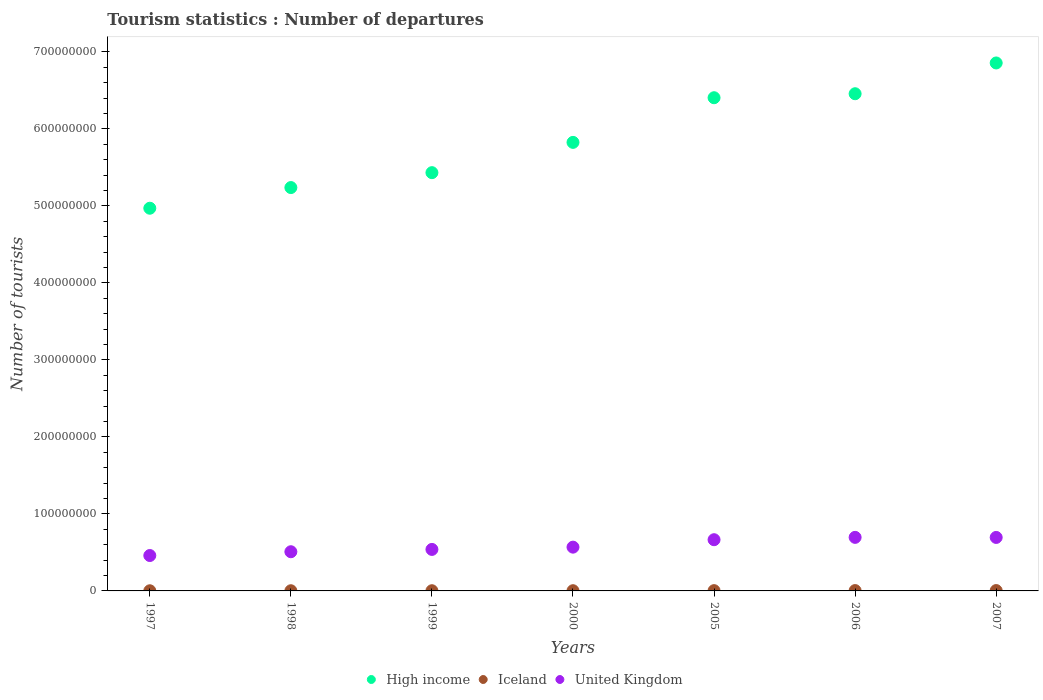How many different coloured dotlines are there?
Offer a terse response. 3. Is the number of dotlines equal to the number of legend labels?
Keep it short and to the point. Yes. What is the number of tourist departures in Iceland in 1999?
Offer a terse response. 2.57e+05. Across all years, what is the maximum number of tourist departures in United Kingdom?
Keep it short and to the point. 6.95e+07. Across all years, what is the minimum number of tourist departures in High income?
Provide a short and direct response. 4.97e+08. In which year was the number of tourist departures in United Kingdom maximum?
Give a very brief answer. 2006. In which year was the number of tourist departures in High income minimum?
Give a very brief answer. 1997. What is the total number of tourist departures in United Kingdom in the graph?
Offer a very short reply. 4.13e+08. What is the difference between the number of tourist departures in United Kingdom in 2006 and that in 2007?
Your answer should be compact. 8.60e+04. What is the difference between the number of tourist departures in Iceland in 2000 and the number of tourist departures in High income in 2005?
Offer a very short reply. -6.40e+08. What is the average number of tourist departures in Iceland per year?
Provide a succinct answer. 3.19e+05. In the year 2006, what is the difference between the number of tourist departures in Iceland and number of tourist departures in High income?
Your response must be concise. -6.45e+08. In how many years, is the number of tourist departures in Iceland greater than 200000000?
Give a very brief answer. 0. What is the ratio of the number of tourist departures in Iceland in 2000 to that in 2005?
Offer a terse response. 0.78. Is the difference between the number of tourist departures in Iceland in 1998 and 1999 greater than the difference between the number of tourist departures in High income in 1998 and 1999?
Provide a succinct answer. Yes. What is the difference between the highest and the second highest number of tourist departures in Iceland?
Keep it short and to the point. 2.00e+04. What is the difference between the highest and the lowest number of tourist departures in High income?
Ensure brevity in your answer.  1.89e+08. Is it the case that in every year, the sum of the number of tourist departures in United Kingdom and number of tourist departures in High income  is greater than the number of tourist departures in Iceland?
Make the answer very short. Yes. Does the number of tourist departures in United Kingdom monotonically increase over the years?
Give a very brief answer. No. Is the number of tourist departures in United Kingdom strictly greater than the number of tourist departures in High income over the years?
Ensure brevity in your answer.  No. How many dotlines are there?
Offer a terse response. 3. What is the difference between two consecutive major ticks on the Y-axis?
Provide a succinct answer. 1.00e+08. Are the values on the major ticks of Y-axis written in scientific E-notation?
Offer a very short reply. No. Does the graph contain any zero values?
Your answer should be very brief. No. Where does the legend appear in the graph?
Your answer should be very brief. Bottom center. How are the legend labels stacked?
Offer a terse response. Horizontal. What is the title of the graph?
Your answer should be compact. Tourism statistics : Number of departures. What is the label or title of the Y-axis?
Provide a succinct answer. Number of tourists. What is the Number of tourists in High income in 1997?
Keep it short and to the point. 4.97e+08. What is the Number of tourists of Iceland in 1997?
Ensure brevity in your answer.  2.03e+05. What is the Number of tourists in United Kingdom in 1997?
Your answer should be compact. 4.60e+07. What is the Number of tourists in High income in 1998?
Make the answer very short. 5.24e+08. What is the Number of tourists in Iceland in 1998?
Provide a succinct answer. 2.27e+05. What is the Number of tourists in United Kingdom in 1998?
Provide a short and direct response. 5.09e+07. What is the Number of tourists of High income in 1999?
Provide a short and direct response. 5.43e+08. What is the Number of tourists in Iceland in 1999?
Ensure brevity in your answer.  2.57e+05. What is the Number of tourists in United Kingdom in 1999?
Keep it short and to the point. 5.39e+07. What is the Number of tourists of High income in 2000?
Your response must be concise. 5.82e+08. What is the Number of tourists in Iceland in 2000?
Your answer should be compact. 2.83e+05. What is the Number of tourists in United Kingdom in 2000?
Offer a terse response. 5.68e+07. What is the Number of tourists in High income in 2005?
Offer a very short reply. 6.40e+08. What is the Number of tourists in Iceland in 2005?
Your response must be concise. 3.64e+05. What is the Number of tourists in United Kingdom in 2005?
Provide a succinct answer. 6.65e+07. What is the Number of tourists of High income in 2006?
Ensure brevity in your answer.  6.46e+08. What is the Number of tourists of Iceland in 2006?
Provide a short and direct response. 4.40e+05. What is the Number of tourists in United Kingdom in 2006?
Keep it short and to the point. 6.95e+07. What is the Number of tourists in High income in 2007?
Offer a terse response. 6.85e+08. What is the Number of tourists in Iceland in 2007?
Give a very brief answer. 4.60e+05. What is the Number of tourists of United Kingdom in 2007?
Keep it short and to the point. 6.94e+07. Across all years, what is the maximum Number of tourists in High income?
Make the answer very short. 6.85e+08. Across all years, what is the maximum Number of tourists of United Kingdom?
Ensure brevity in your answer.  6.95e+07. Across all years, what is the minimum Number of tourists of High income?
Provide a short and direct response. 4.97e+08. Across all years, what is the minimum Number of tourists in Iceland?
Offer a very short reply. 2.03e+05. Across all years, what is the minimum Number of tourists of United Kingdom?
Your answer should be compact. 4.60e+07. What is the total Number of tourists of High income in the graph?
Ensure brevity in your answer.  4.12e+09. What is the total Number of tourists of Iceland in the graph?
Offer a terse response. 2.23e+06. What is the total Number of tourists in United Kingdom in the graph?
Keep it short and to the point. 4.13e+08. What is the difference between the Number of tourists of High income in 1997 and that in 1998?
Offer a very short reply. -2.68e+07. What is the difference between the Number of tourists of Iceland in 1997 and that in 1998?
Your response must be concise. -2.40e+04. What is the difference between the Number of tourists of United Kingdom in 1997 and that in 1998?
Your answer should be compact. -4.92e+06. What is the difference between the Number of tourists in High income in 1997 and that in 1999?
Offer a very short reply. -4.62e+07. What is the difference between the Number of tourists in Iceland in 1997 and that in 1999?
Provide a succinct answer. -5.40e+04. What is the difference between the Number of tourists in United Kingdom in 1997 and that in 1999?
Make the answer very short. -7.92e+06. What is the difference between the Number of tourists in High income in 1997 and that in 2000?
Offer a very short reply. -8.55e+07. What is the difference between the Number of tourists of Iceland in 1997 and that in 2000?
Provide a succinct answer. -8.00e+04. What is the difference between the Number of tourists of United Kingdom in 1997 and that in 2000?
Provide a short and direct response. -1.09e+07. What is the difference between the Number of tourists of High income in 1997 and that in 2005?
Your answer should be compact. -1.43e+08. What is the difference between the Number of tourists in Iceland in 1997 and that in 2005?
Your response must be concise. -1.61e+05. What is the difference between the Number of tourists of United Kingdom in 1997 and that in 2005?
Provide a succinct answer. -2.05e+07. What is the difference between the Number of tourists in High income in 1997 and that in 2006?
Your answer should be very brief. -1.49e+08. What is the difference between the Number of tourists in Iceland in 1997 and that in 2006?
Provide a short and direct response. -2.37e+05. What is the difference between the Number of tourists of United Kingdom in 1997 and that in 2006?
Give a very brief answer. -2.36e+07. What is the difference between the Number of tourists of High income in 1997 and that in 2007?
Your answer should be very brief. -1.89e+08. What is the difference between the Number of tourists in Iceland in 1997 and that in 2007?
Your response must be concise. -2.57e+05. What is the difference between the Number of tourists of United Kingdom in 1997 and that in 2007?
Your answer should be very brief. -2.35e+07. What is the difference between the Number of tourists of High income in 1998 and that in 1999?
Your answer should be compact. -1.94e+07. What is the difference between the Number of tourists in United Kingdom in 1998 and that in 1999?
Offer a terse response. -3.01e+06. What is the difference between the Number of tourists of High income in 1998 and that in 2000?
Make the answer very short. -5.87e+07. What is the difference between the Number of tourists of Iceland in 1998 and that in 2000?
Your response must be concise. -5.60e+04. What is the difference between the Number of tourists in United Kingdom in 1998 and that in 2000?
Ensure brevity in your answer.  -5.96e+06. What is the difference between the Number of tourists in High income in 1998 and that in 2005?
Your answer should be compact. -1.17e+08. What is the difference between the Number of tourists in Iceland in 1998 and that in 2005?
Ensure brevity in your answer.  -1.37e+05. What is the difference between the Number of tourists in United Kingdom in 1998 and that in 2005?
Offer a terse response. -1.56e+07. What is the difference between the Number of tourists in High income in 1998 and that in 2006?
Make the answer very short. -1.22e+08. What is the difference between the Number of tourists in Iceland in 1998 and that in 2006?
Ensure brevity in your answer.  -2.13e+05. What is the difference between the Number of tourists of United Kingdom in 1998 and that in 2006?
Provide a short and direct response. -1.87e+07. What is the difference between the Number of tourists of High income in 1998 and that in 2007?
Give a very brief answer. -1.62e+08. What is the difference between the Number of tourists in Iceland in 1998 and that in 2007?
Your answer should be compact. -2.33e+05. What is the difference between the Number of tourists of United Kingdom in 1998 and that in 2007?
Provide a succinct answer. -1.86e+07. What is the difference between the Number of tourists in High income in 1999 and that in 2000?
Ensure brevity in your answer.  -3.93e+07. What is the difference between the Number of tourists in Iceland in 1999 and that in 2000?
Offer a terse response. -2.60e+04. What is the difference between the Number of tourists of United Kingdom in 1999 and that in 2000?
Make the answer very short. -2.96e+06. What is the difference between the Number of tourists of High income in 1999 and that in 2005?
Your answer should be compact. -9.73e+07. What is the difference between the Number of tourists in Iceland in 1999 and that in 2005?
Make the answer very short. -1.07e+05. What is the difference between the Number of tourists of United Kingdom in 1999 and that in 2005?
Your answer should be compact. -1.26e+07. What is the difference between the Number of tourists of High income in 1999 and that in 2006?
Keep it short and to the point. -1.02e+08. What is the difference between the Number of tourists of Iceland in 1999 and that in 2006?
Your answer should be very brief. -1.83e+05. What is the difference between the Number of tourists of United Kingdom in 1999 and that in 2006?
Ensure brevity in your answer.  -1.57e+07. What is the difference between the Number of tourists of High income in 1999 and that in 2007?
Offer a very short reply. -1.42e+08. What is the difference between the Number of tourists of Iceland in 1999 and that in 2007?
Your answer should be compact. -2.03e+05. What is the difference between the Number of tourists of United Kingdom in 1999 and that in 2007?
Offer a terse response. -1.56e+07. What is the difference between the Number of tourists in High income in 2000 and that in 2005?
Provide a short and direct response. -5.80e+07. What is the difference between the Number of tourists in Iceland in 2000 and that in 2005?
Your answer should be compact. -8.10e+04. What is the difference between the Number of tourists in United Kingdom in 2000 and that in 2005?
Provide a short and direct response. -9.66e+06. What is the difference between the Number of tourists of High income in 2000 and that in 2006?
Ensure brevity in your answer.  -6.32e+07. What is the difference between the Number of tourists in Iceland in 2000 and that in 2006?
Give a very brief answer. -1.57e+05. What is the difference between the Number of tourists of United Kingdom in 2000 and that in 2006?
Make the answer very short. -1.27e+07. What is the difference between the Number of tourists in High income in 2000 and that in 2007?
Provide a short and direct response. -1.03e+08. What is the difference between the Number of tourists of Iceland in 2000 and that in 2007?
Keep it short and to the point. -1.77e+05. What is the difference between the Number of tourists in United Kingdom in 2000 and that in 2007?
Provide a succinct answer. -1.26e+07. What is the difference between the Number of tourists in High income in 2005 and that in 2006?
Your answer should be compact. -5.19e+06. What is the difference between the Number of tourists in Iceland in 2005 and that in 2006?
Keep it short and to the point. -7.60e+04. What is the difference between the Number of tourists of United Kingdom in 2005 and that in 2006?
Keep it short and to the point. -3.04e+06. What is the difference between the Number of tourists in High income in 2005 and that in 2007?
Give a very brief answer. -4.51e+07. What is the difference between the Number of tourists in Iceland in 2005 and that in 2007?
Make the answer very short. -9.60e+04. What is the difference between the Number of tourists in United Kingdom in 2005 and that in 2007?
Ensure brevity in your answer.  -2.96e+06. What is the difference between the Number of tourists of High income in 2006 and that in 2007?
Provide a short and direct response. -3.99e+07. What is the difference between the Number of tourists in United Kingdom in 2006 and that in 2007?
Ensure brevity in your answer.  8.60e+04. What is the difference between the Number of tourists of High income in 1997 and the Number of tourists of Iceland in 1998?
Offer a very short reply. 4.97e+08. What is the difference between the Number of tourists in High income in 1997 and the Number of tourists in United Kingdom in 1998?
Your answer should be very brief. 4.46e+08. What is the difference between the Number of tourists in Iceland in 1997 and the Number of tourists in United Kingdom in 1998?
Offer a very short reply. -5.07e+07. What is the difference between the Number of tourists in High income in 1997 and the Number of tourists in Iceland in 1999?
Provide a succinct answer. 4.97e+08. What is the difference between the Number of tourists in High income in 1997 and the Number of tourists in United Kingdom in 1999?
Ensure brevity in your answer.  4.43e+08. What is the difference between the Number of tourists of Iceland in 1997 and the Number of tourists of United Kingdom in 1999?
Your answer should be very brief. -5.37e+07. What is the difference between the Number of tourists in High income in 1997 and the Number of tourists in Iceland in 2000?
Offer a very short reply. 4.97e+08. What is the difference between the Number of tourists of High income in 1997 and the Number of tourists of United Kingdom in 2000?
Offer a very short reply. 4.40e+08. What is the difference between the Number of tourists in Iceland in 1997 and the Number of tourists in United Kingdom in 2000?
Provide a short and direct response. -5.66e+07. What is the difference between the Number of tourists in High income in 1997 and the Number of tourists in Iceland in 2005?
Provide a succinct answer. 4.97e+08. What is the difference between the Number of tourists in High income in 1997 and the Number of tourists in United Kingdom in 2005?
Offer a very short reply. 4.30e+08. What is the difference between the Number of tourists of Iceland in 1997 and the Number of tourists of United Kingdom in 2005?
Keep it short and to the point. -6.63e+07. What is the difference between the Number of tourists in High income in 1997 and the Number of tourists in Iceland in 2006?
Make the answer very short. 4.96e+08. What is the difference between the Number of tourists of High income in 1997 and the Number of tourists of United Kingdom in 2006?
Offer a very short reply. 4.27e+08. What is the difference between the Number of tourists of Iceland in 1997 and the Number of tourists of United Kingdom in 2006?
Provide a succinct answer. -6.93e+07. What is the difference between the Number of tourists in High income in 1997 and the Number of tourists in Iceland in 2007?
Provide a succinct answer. 4.96e+08. What is the difference between the Number of tourists of High income in 1997 and the Number of tourists of United Kingdom in 2007?
Provide a short and direct response. 4.27e+08. What is the difference between the Number of tourists of Iceland in 1997 and the Number of tourists of United Kingdom in 2007?
Your response must be concise. -6.92e+07. What is the difference between the Number of tourists in High income in 1998 and the Number of tourists in Iceland in 1999?
Provide a succinct answer. 5.23e+08. What is the difference between the Number of tourists of High income in 1998 and the Number of tourists of United Kingdom in 1999?
Provide a short and direct response. 4.70e+08. What is the difference between the Number of tourists in Iceland in 1998 and the Number of tourists in United Kingdom in 1999?
Offer a terse response. -5.37e+07. What is the difference between the Number of tourists of High income in 1998 and the Number of tourists of Iceland in 2000?
Your answer should be very brief. 5.23e+08. What is the difference between the Number of tourists in High income in 1998 and the Number of tourists in United Kingdom in 2000?
Offer a terse response. 4.67e+08. What is the difference between the Number of tourists in Iceland in 1998 and the Number of tourists in United Kingdom in 2000?
Give a very brief answer. -5.66e+07. What is the difference between the Number of tourists in High income in 1998 and the Number of tourists in Iceland in 2005?
Provide a succinct answer. 5.23e+08. What is the difference between the Number of tourists of High income in 1998 and the Number of tourists of United Kingdom in 2005?
Your answer should be compact. 4.57e+08. What is the difference between the Number of tourists in Iceland in 1998 and the Number of tourists in United Kingdom in 2005?
Ensure brevity in your answer.  -6.63e+07. What is the difference between the Number of tourists of High income in 1998 and the Number of tourists of Iceland in 2006?
Offer a very short reply. 5.23e+08. What is the difference between the Number of tourists of High income in 1998 and the Number of tourists of United Kingdom in 2006?
Ensure brevity in your answer.  4.54e+08. What is the difference between the Number of tourists of Iceland in 1998 and the Number of tourists of United Kingdom in 2006?
Offer a terse response. -6.93e+07. What is the difference between the Number of tourists in High income in 1998 and the Number of tourists in Iceland in 2007?
Offer a very short reply. 5.23e+08. What is the difference between the Number of tourists of High income in 1998 and the Number of tourists of United Kingdom in 2007?
Give a very brief answer. 4.54e+08. What is the difference between the Number of tourists of Iceland in 1998 and the Number of tourists of United Kingdom in 2007?
Your answer should be very brief. -6.92e+07. What is the difference between the Number of tourists of High income in 1999 and the Number of tourists of Iceland in 2000?
Ensure brevity in your answer.  5.43e+08. What is the difference between the Number of tourists in High income in 1999 and the Number of tourists in United Kingdom in 2000?
Ensure brevity in your answer.  4.86e+08. What is the difference between the Number of tourists of Iceland in 1999 and the Number of tourists of United Kingdom in 2000?
Make the answer very short. -5.66e+07. What is the difference between the Number of tourists in High income in 1999 and the Number of tourists in Iceland in 2005?
Make the answer very short. 5.43e+08. What is the difference between the Number of tourists of High income in 1999 and the Number of tourists of United Kingdom in 2005?
Your answer should be compact. 4.77e+08. What is the difference between the Number of tourists in Iceland in 1999 and the Number of tourists in United Kingdom in 2005?
Ensure brevity in your answer.  -6.62e+07. What is the difference between the Number of tourists in High income in 1999 and the Number of tourists in Iceland in 2006?
Ensure brevity in your answer.  5.43e+08. What is the difference between the Number of tourists of High income in 1999 and the Number of tourists of United Kingdom in 2006?
Your response must be concise. 4.74e+08. What is the difference between the Number of tourists of Iceland in 1999 and the Number of tourists of United Kingdom in 2006?
Ensure brevity in your answer.  -6.93e+07. What is the difference between the Number of tourists of High income in 1999 and the Number of tourists of Iceland in 2007?
Make the answer very short. 5.43e+08. What is the difference between the Number of tourists in High income in 1999 and the Number of tourists in United Kingdom in 2007?
Your response must be concise. 4.74e+08. What is the difference between the Number of tourists of Iceland in 1999 and the Number of tourists of United Kingdom in 2007?
Make the answer very short. -6.92e+07. What is the difference between the Number of tourists of High income in 2000 and the Number of tourists of Iceland in 2005?
Your answer should be compact. 5.82e+08. What is the difference between the Number of tourists in High income in 2000 and the Number of tourists in United Kingdom in 2005?
Offer a terse response. 5.16e+08. What is the difference between the Number of tourists in Iceland in 2000 and the Number of tourists in United Kingdom in 2005?
Your answer should be very brief. -6.62e+07. What is the difference between the Number of tourists of High income in 2000 and the Number of tourists of Iceland in 2006?
Keep it short and to the point. 5.82e+08. What is the difference between the Number of tourists of High income in 2000 and the Number of tourists of United Kingdom in 2006?
Ensure brevity in your answer.  5.13e+08. What is the difference between the Number of tourists in Iceland in 2000 and the Number of tourists in United Kingdom in 2006?
Keep it short and to the point. -6.93e+07. What is the difference between the Number of tourists of High income in 2000 and the Number of tourists of Iceland in 2007?
Your answer should be very brief. 5.82e+08. What is the difference between the Number of tourists of High income in 2000 and the Number of tourists of United Kingdom in 2007?
Keep it short and to the point. 5.13e+08. What is the difference between the Number of tourists of Iceland in 2000 and the Number of tourists of United Kingdom in 2007?
Give a very brief answer. -6.92e+07. What is the difference between the Number of tourists in High income in 2005 and the Number of tourists in Iceland in 2006?
Provide a short and direct response. 6.40e+08. What is the difference between the Number of tourists of High income in 2005 and the Number of tourists of United Kingdom in 2006?
Keep it short and to the point. 5.71e+08. What is the difference between the Number of tourists in Iceland in 2005 and the Number of tourists in United Kingdom in 2006?
Offer a terse response. -6.92e+07. What is the difference between the Number of tourists of High income in 2005 and the Number of tourists of Iceland in 2007?
Your answer should be compact. 6.40e+08. What is the difference between the Number of tourists in High income in 2005 and the Number of tourists in United Kingdom in 2007?
Ensure brevity in your answer.  5.71e+08. What is the difference between the Number of tourists in Iceland in 2005 and the Number of tourists in United Kingdom in 2007?
Provide a short and direct response. -6.91e+07. What is the difference between the Number of tourists in High income in 2006 and the Number of tourists in Iceland in 2007?
Offer a terse response. 6.45e+08. What is the difference between the Number of tourists in High income in 2006 and the Number of tourists in United Kingdom in 2007?
Make the answer very short. 5.76e+08. What is the difference between the Number of tourists of Iceland in 2006 and the Number of tourists of United Kingdom in 2007?
Your answer should be compact. -6.90e+07. What is the average Number of tourists of High income per year?
Your response must be concise. 5.88e+08. What is the average Number of tourists in Iceland per year?
Offer a terse response. 3.19e+05. What is the average Number of tourists of United Kingdom per year?
Give a very brief answer. 5.90e+07. In the year 1997, what is the difference between the Number of tourists of High income and Number of tourists of Iceland?
Give a very brief answer. 4.97e+08. In the year 1997, what is the difference between the Number of tourists in High income and Number of tourists in United Kingdom?
Keep it short and to the point. 4.51e+08. In the year 1997, what is the difference between the Number of tourists in Iceland and Number of tourists in United Kingdom?
Ensure brevity in your answer.  -4.58e+07. In the year 1998, what is the difference between the Number of tourists of High income and Number of tourists of Iceland?
Offer a terse response. 5.23e+08. In the year 1998, what is the difference between the Number of tourists of High income and Number of tourists of United Kingdom?
Your response must be concise. 4.73e+08. In the year 1998, what is the difference between the Number of tourists of Iceland and Number of tourists of United Kingdom?
Offer a terse response. -5.06e+07. In the year 1999, what is the difference between the Number of tourists in High income and Number of tourists in Iceland?
Offer a terse response. 5.43e+08. In the year 1999, what is the difference between the Number of tourists of High income and Number of tourists of United Kingdom?
Your response must be concise. 4.89e+08. In the year 1999, what is the difference between the Number of tourists of Iceland and Number of tourists of United Kingdom?
Keep it short and to the point. -5.36e+07. In the year 2000, what is the difference between the Number of tourists in High income and Number of tourists in Iceland?
Give a very brief answer. 5.82e+08. In the year 2000, what is the difference between the Number of tourists in High income and Number of tourists in United Kingdom?
Make the answer very short. 5.26e+08. In the year 2000, what is the difference between the Number of tourists in Iceland and Number of tourists in United Kingdom?
Your answer should be very brief. -5.66e+07. In the year 2005, what is the difference between the Number of tourists in High income and Number of tourists in Iceland?
Offer a very short reply. 6.40e+08. In the year 2005, what is the difference between the Number of tourists of High income and Number of tourists of United Kingdom?
Your response must be concise. 5.74e+08. In the year 2005, what is the difference between the Number of tourists in Iceland and Number of tourists in United Kingdom?
Ensure brevity in your answer.  -6.61e+07. In the year 2006, what is the difference between the Number of tourists of High income and Number of tourists of Iceland?
Offer a very short reply. 6.45e+08. In the year 2006, what is the difference between the Number of tourists in High income and Number of tourists in United Kingdom?
Your response must be concise. 5.76e+08. In the year 2006, what is the difference between the Number of tourists of Iceland and Number of tourists of United Kingdom?
Your answer should be very brief. -6.91e+07. In the year 2007, what is the difference between the Number of tourists of High income and Number of tourists of Iceland?
Give a very brief answer. 6.85e+08. In the year 2007, what is the difference between the Number of tourists in High income and Number of tourists in United Kingdom?
Your answer should be compact. 6.16e+08. In the year 2007, what is the difference between the Number of tourists of Iceland and Number of tourists of United Kingdom?
Keep it short and to the point. -6.90e+07. What is the ratio of the Number of tourists of High income in 1997 to that in 1998?
Keep it short and to the point. 0.95. What is the ratio of the Number of tourists in Iceland in 1997 to that in 1998?
Ensure brevity in your answer.  0.89. What is the ratio of the Number of tourists in United Kingdom in 1997 to that in 1998?
Provide a short and direct response. 0.9. What is the ratio of the Number of tourists of High income in 1997 to that in 1999?
Keep it short and to the point. 0.92. What is the ratio of the Number of tourists of Iceland in 1997 to that in 1999?
Your answer should be compact. 0.79. What is the ratio of the Number of tourists in United Kingdom in 1997 to that in 1999?
Your response must be concise. 0.85. What is the ratio of the Number of tourists in High income in 1997 to that in 2000?
Your response must be concise. 0.85. What is the ratio of the Number of tourists of Iceland in 1997 to that in 2000?
Offer a terse response. 0.72. What is the ratio of the Number of tourists in United Kingdom in 1997 to that in 2000?
Your answer should be compact. 0.81. What is the ratio of the Number of tourists in High income in 1997 to that in 2005?
Your response must be concise. 0.78. What is the ratio of the Number of tourists of Iceland in 1997 to that in 2005?
Offer a terse response. 0.56. What is the ratio of the Number of tourists of United Kingdom in 1997 to that in 2005?
Give a very brief answer. 0.69. What is the ratio of the Number of tourists of High income in 1997 to that in 2006?
Ensure brevity in your answer.  0.77. What is the ratio of the Number of tourists in Iceland in 1997 to that in 2006?
Your answer should be compact. 0.46. What is the ratio of the Number of tourists in United Kingdom in 1997 to that in 2006?
Make the answer very short. 0.66. What is the ratio of the Number of tourists in High income in 1997 to that in 2007?
Make the answer very short. 0.72. What is the ratio of the Number of tourists of Iceland in 1997 to that in 2007?
Your answer should be compact. 0.44. What is the ratio of the Number of tourists in United Kingdom in 1997 to that in 2007?
Your answer should be very brief. 0.66. What is the ratio of the Number of tourists of High income in 1998 to that in 1999?
Your response must be concise. 0.96. What is the ratio of the Number of tourists in Iceland in 1998 to that in 1999?
Provide a succinct answer. 0.88. What is the ratio of the Number of tourists in United Kingdom in 1998 to that in 1999?
Make the answer very short. 0.94. What is the ratio of the Number of tourists in High income in 1998 to that in 2000?
Provide a short and direct response. 0.9. What is the ratio of the Number of tourists of Iceland in 1998 to that in 2000?
Your answer should be very brief. 0.8. What is the ratio of the Number of tourists in United Kingdom in 1998 to that in 2000?
Your answer should be compact. 0.9. What is the ratio of the Number of tourists of High income in 1998 to that in 2005?
Ensure brevity in your answer.  0.82. What is the ratio of the Number of tourists in Iceland in 1998 to that in 2005?
Your answer should be compact. 0.62. What is the ratio of the Number of tourists in United Kingdom in 1998 to that in 2005?
Provide a short and direct response. 0.77. What is the ratio of the Number of tourists of High income in 1998 to that in 2006?
Your answer should be compact. 0.81. What is the ratio of the Number of tourists of Iceland in 1998 to that in 2006?
Provide a short and direct response. 0.52. What is the ratio of the Number of tourists of United Kingdom in 1998 to that in 2006?
Provide a short and direct response. 0.73. What is the ratio of the Number of tourists in High income in 1998 to that in 2007?
Ensure brevity in your answer.  0.76. What is the ratio of the Number of tourists of Iceland in 1998 to that in 2007?
Your response must be concise. 0.49. What is the ratio of the Number of tourists in United Kingdom in 1998 to that in 2007?
Offer a very short reply. 0.73. What is the ratio of the Number of tourists of High income in 1999 to that in 2000?
Your response must be concise. 0.93. What is the ratio of the Number of tourists in Iceland in 1999 to that in 2000?
Provide a short and direct response. 0.91. What is the ratio of the Number of tourists of United Kingdom in 1999 to that in 2000?
Your answer should be compact. 0.95. What is the ratio of the Number of tourists of High income in 1999 to that in 2005?
Provide a succinct answer. 0.85. What is the ratio of the Number of tourists in Iceland in 1999 to that in 2005?
Your response must be concise. 0.71. What is the ratio of the Number of tourists in United Kingdom in 1999 to that in 2005?
Your answer should be compact. 0.81. What is the ratio of the Number of tourists of High income in 1999 to that in 2006?
Offer a terse response. 0.84. What is the ratio of the Number of tourists in Iceland in 1999 to that in 2006?
Ensure brevity in your answer.  0.58. What is the ratio of the Number of tourists in United Kingdom in 1999 to that in 2006?
Ensure brevity in your answer.  0.77. What is the ratio of the Number of tourists of High income in 1999 to that in 2007?
Your answer should be compact. 0.79. What is the ratio of the Number of tourists in Iceland in 1999 to that in 2007?
Provide a succinct answer. 0.56. What is the ratio of the Number of tourists of United Kingdom in 1999 to that in 2007?
Offer a terse response. 0.78. What is the ratio of the Number of tourists in High income in 2000 to that in 2005?
Provide a succinct answer. 0.91. What is the ratio of the Number of tourists of Iceland in 2000 to that in 2005?
Your answer should be compact. 0.78. What is the ratio of the Number of tourists of United Kingdom in 2000 to that in 2005?
Keep it short and to the point. 0.85. What is the ratio of the Number of tourists of High income in 2000 to that in 2006?
Offer a terse response. 0.9. What is the ratio of the Number of tourists of Iceland in 2000 to that in 2006?
Provide a succinct answer. 0.64. What is the ratio of the Number of tourists of United Kingdom in 2000 to that in 2006?
Provide a short and direct response. 0.82. What is the ratio of the Number of tourists of High income in 2000 to that in 2007?
Provide a succinct answer. 0.85. What is the ratio of the Number of tourists of Iceland in 2000 to that in 2007?
Keep it short and to the point. 0.62. What is the ratio of the Number of tourists in United Kingdom in 2000 to that in 2007?
Provide a short and direct response. 0.82. What is the ratio of the Number of tourists of Iceland in 2005 to that in 2006?
Ensure brevity in your answer.  0.83. What is the ratio of the Number of tourists of United Kingdom in 2005 to that in 2006?
Give a very brief answer. 0.96. What is the ratio of the Number of tourists in High income in 2005 to that in 2007?
Keep it short and to the point. 0.93. What is the ratio of the Number of tourists in Iceland in 2005 to that in 2007?
Your response must be concise. 0.79. What is the ratio of the Number of tourists of United Kingdom in 2005 to that in 2007?
Your response must be concise. 0.96. What is the ratio of the Number of tourists of High income in 2006 to that in 2007?
Offer a very short reply. 0.94. What is the ratio of the Number of tourists in Iceland in 2006 to that in 2007?
Make the answer very short. 0.96. What is the difference between the highest and the second highest Number of tourists of High income?
Your answer should be very brief. 3.99e+07. What is the difference between the highest and the second highest Number of tourists in United Kingdom?
Offer a very short reply. 8.60e+04. What is the difference between the highest and the lowest Number of tourists of High income?
Give a very brief answer. 1.89e+08. What is the difference between the highest and the lowest Number of tourists in Iceland?
Offer a very short reply. 2.57e+05. What is the difference between the highest and the lowest Number of tourists of United Kingdom?
Offer a terse response. 2.36e+07. 